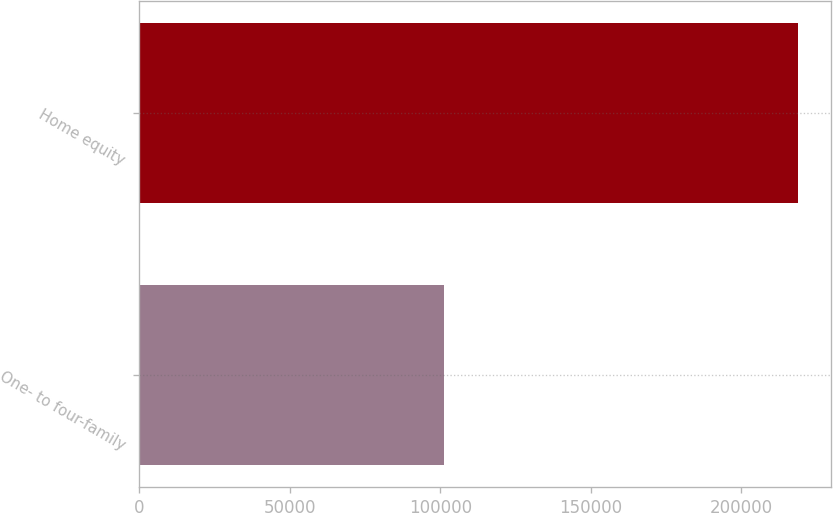Convert chart to OTSL. <chart><loc_0><loc_0><loc_500><loc_500><bar_chart><fcel>One- to four-family<fcel>Home equity<nl><fcel>101188<fcel>218955<nl></chart> 